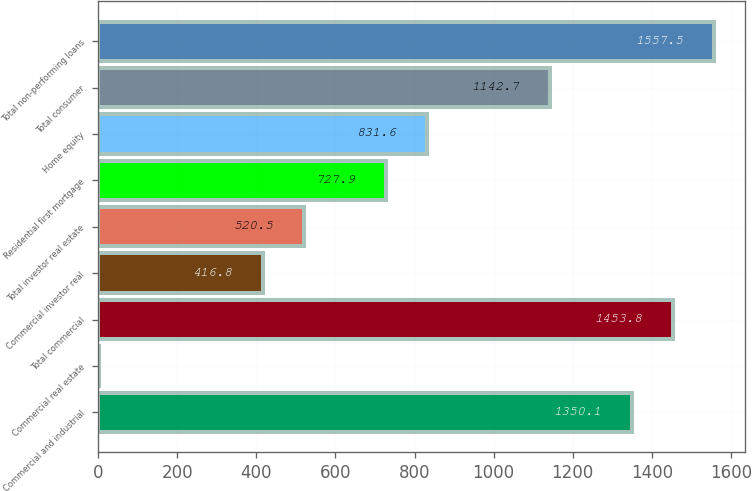<chart> <loc_0><loc_0><loc_500><loc_500><bar_chart><fcel>Commercial and industrial<fcel>Commercial real estate<fcel>Total commercial<fcel>Commercial investor real<fcel>Total investor real estate<fcel>Residential first mortgage<fcel>Home equity<fcel>Total consumer<fcel>Total non-performing loans<nl><fcel>1350.1<fcel>2<fcel>1453.8<fcel>416.8<fcel>520.5<fcel>727.9<fcel>831.6<fcel>1142.7<fcel>1557.5<nl></chart> 